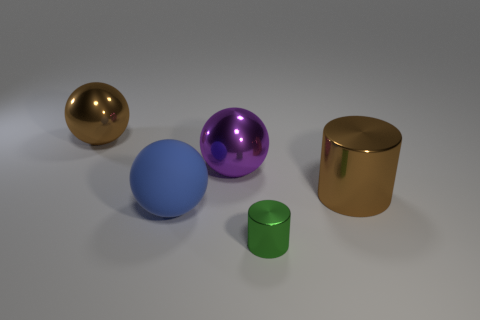Does the big metallic thing that is on the right side of the tiny shiny cylinder have the same color as the small shiny object?
Your response must be concise. No. The other metallic thing that is the same shape as the small thing is what size?
Give a very brief answer. Large. Is there any other thing that is the same size as the green metallic object?
Offer a very short reply. No. There is a big sphere in front of the metal sphere in front of the large brown thing to the left of the tiny green metallic object; what is its material?
Your answer should be compact. Rubber. Is the number of big things in front of the purple sphere greater than the number of green cylinders in front of the green cylinder?
Your response must be concise. Yes. Is the size of the brown metallic cylinder the same as the green metallic cylinder?
Provide a succinct answer. No. What is the color of the large shiny thing that is the same shape as the tiny thing?
Your answer should be compact. Brown. How many big metallic things are the same color as the small metal object?
Provide a short and direct response. 0. Are there more big balls that are in front of the big purple metal sphere than blue objects?
Keep it short and to the point. No. There is a object that is to the right of the small green metallic object on the left side of the large brown cylinder; what is its color?
Your response must be concise. Brown. 